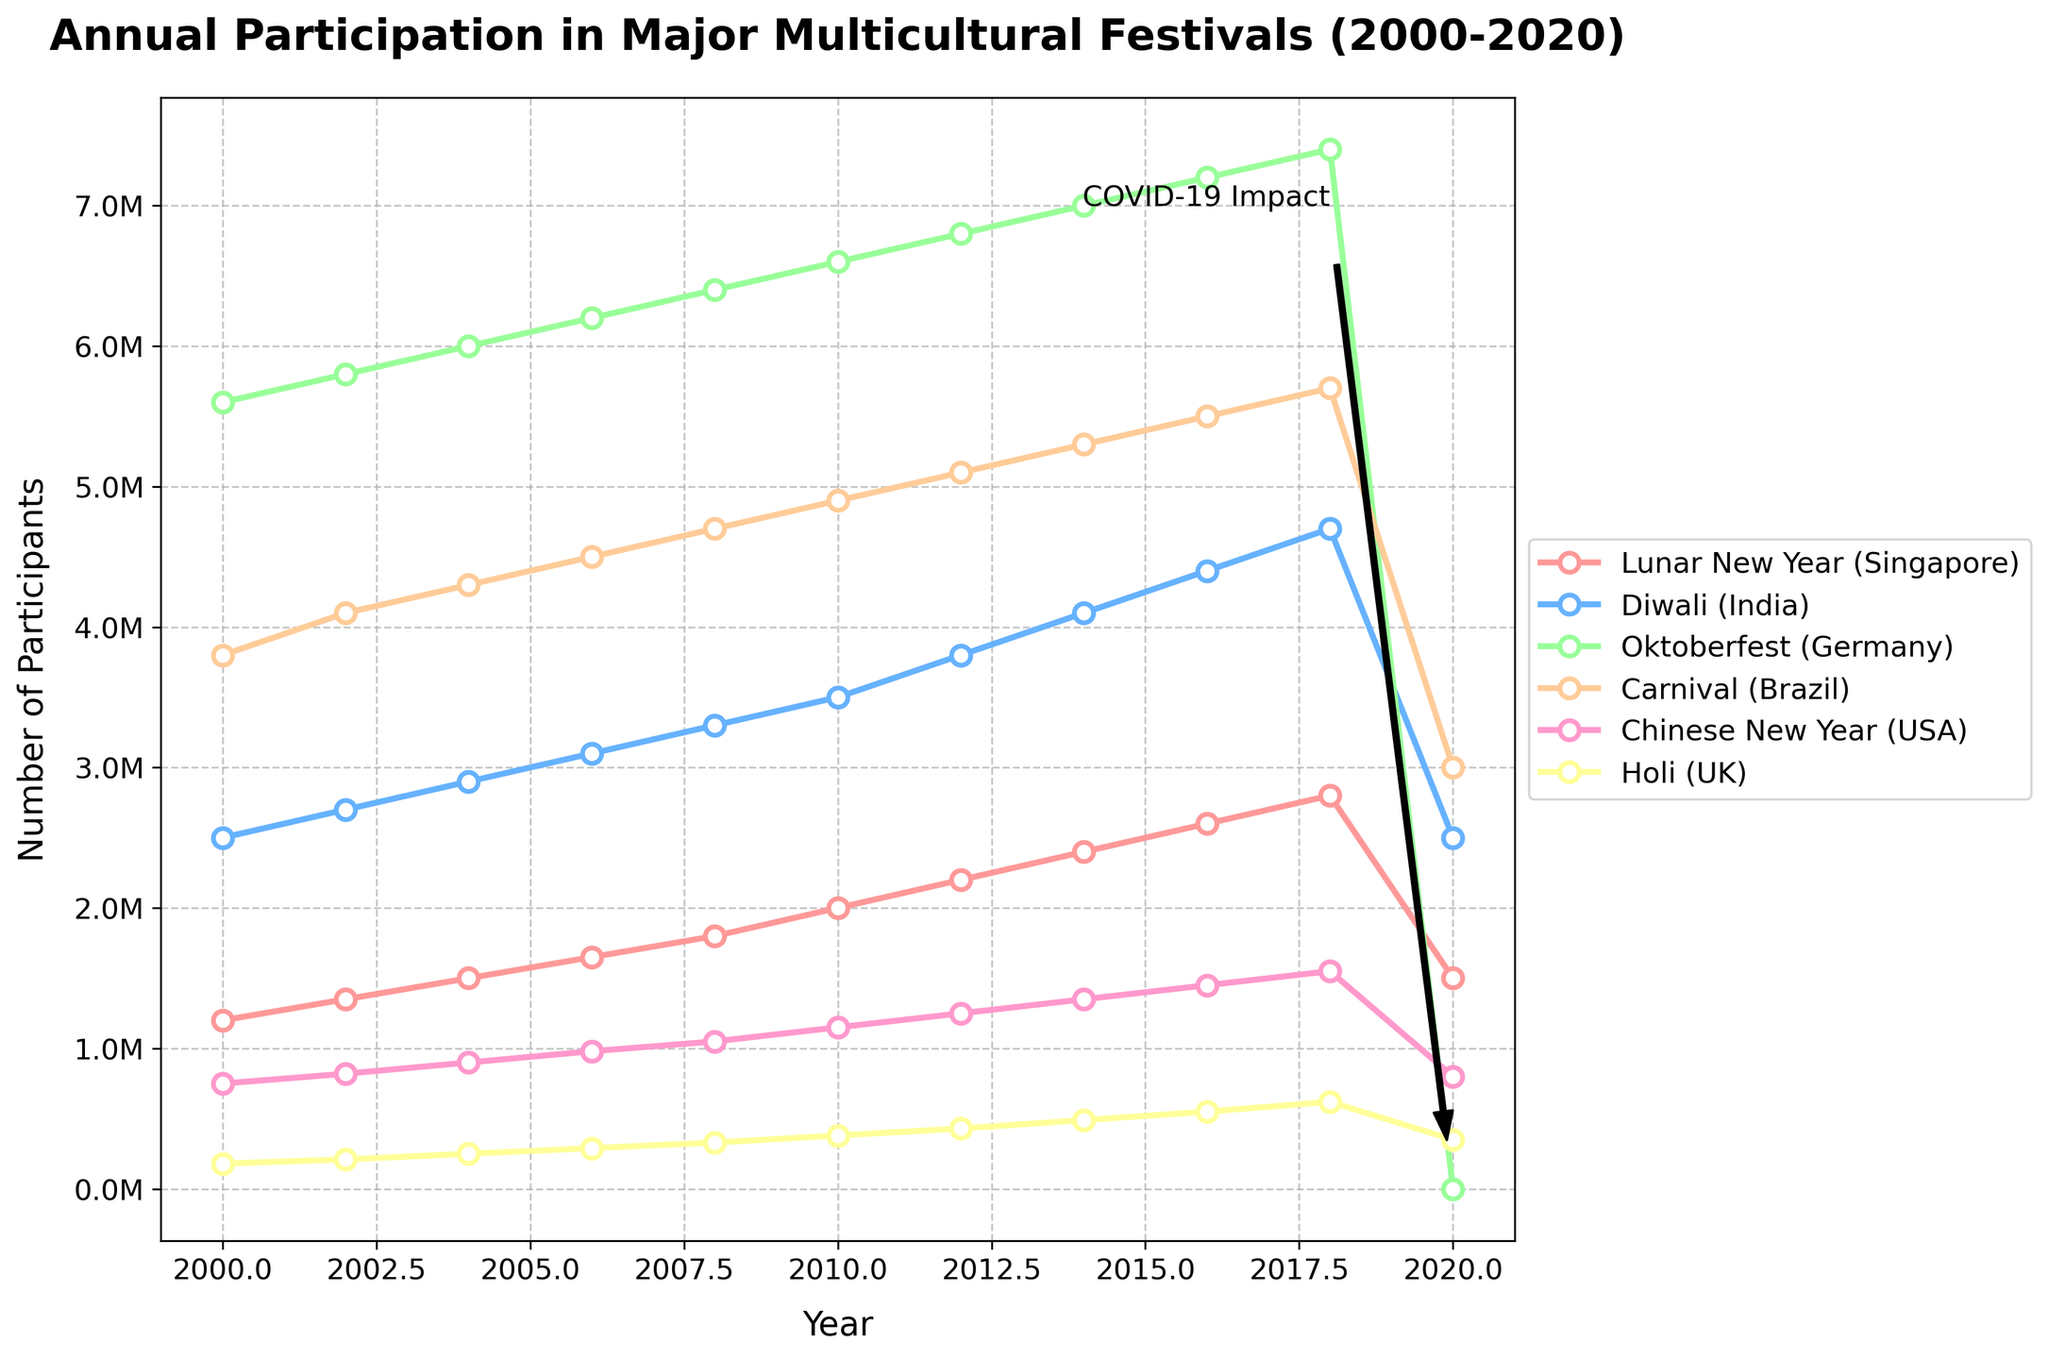What's the participation trend for Diwali in India from 2000 to 2020? The participation for Diwali in India shows a steady increase from 2,500,000 in 2000 to a peak of 4,700,000 in 2018, followed by a sharp drop back to 2,500,000 in 2020.
Answer: Steady increase until 2018, then sharp drop Which festival had the highest participation in 2010? The Oktoberfest (Germany) had the highest participation in 2010 with 6,600,000 participants.
Answer: Oktoberfest (Germany) Compare the participation rates of Lunar New Year in Singapore and the Chinese New Year in the USA in 2020. Which one had more participants? In 2020, Lunar New Year (Singapore) had 1,500,000 participants, while the Chinese New Year (USA) had 800,000 participants. Lunar New Year (Singapore) had more participants.
Answer: Lunar New Year (Singapore) How did the participation in the Carnival in Brazil change between 2018 and 2020? Participation in the Carnival in Brazil decreased significantly from 5,700,000 in 2018 to 3,000,000 in 2020.
Answer: Decreased significantly What is the average participation for Holi (UK) from 2000 to 2020? Sum the participation numbers for Holi from 2000 to 2020 (180,000 + 210,000 + 250,000 + 290,000 + 330,000 + 380,000 + 430,000 + 490,000 + 550,000 + 620,000 + 350,000) = 3,880,000. There are 11 data points, so the average is 3,880,000 / 11 ≈ 352,727.
Answer: Approximately 352,727 Compare the trend of participation for Holi (UK) with Diwali (India) between 2000 and 2020. Both festivals show an increasing trend until 2018, but Diwali has consistently higher participation numbers compared to Holi. In 2020, both festivals see a drop, but Holi's drop is less severe.
Answer: Both increased, Diwali higher, both dropped in 2020 Which festival shows a complete drop in participation to zero in 2020? The Oktoberfest (Germany) shows a complete drop in participation to zero in 2020.
Answer: Oktoberfest (Germany) Between Lunar New Year in Singapore and Carnival in Brazil, which one had a larger decline in participants from 2018 to 2020? Lunar New Year in Singapore declined from 2,800,000 to 1,500,000 (1,300,000 decline) while Carnival in Brazil declined from 5,700,000 to 3,000,000 (2,700,000 decline). Carnival in Brazil had a larger decline in participants.
Answer: Carnival in Brazil 